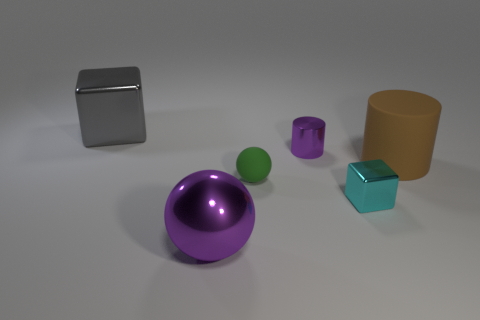Is there any other thing that has the same color as the large metallic ball?
Keep it short and to the point. Yes. There is a block that is left of the purple object on the right side of the small matte object; what is its color?
Keep it short and to the point. Gray. What is the material of the cube that is right of the shiny block behind the cube that is on the right side of the purple cylinder?
Keep it short and to the point. Metal. How many gray rubber spheres are the same size as the purple ball?
Give a very brief answer. 0. What material is the thing that is both in front of the green matte ball and behind the purple sphere?
Offer a terse response. Metal. There is a green rubber ball; what number of cyan objects are to the right of it?
Offer a terse response. 1. Do the big brown thing and the purple metal object that is in front of the green rubber sphere have the same shape?
Your answer should be compact. No. Are there any other green rubber things of the same shape as the green object?
Ensure brevity in your answer.  No. What shape is the large metal thing in front of the large thing that is behind the large matte thing?
Provide a succinct answer. Sphere. What shape is the small metallic object that is behind the green matte ball?
Provide a short and direct response. Cylinder. 